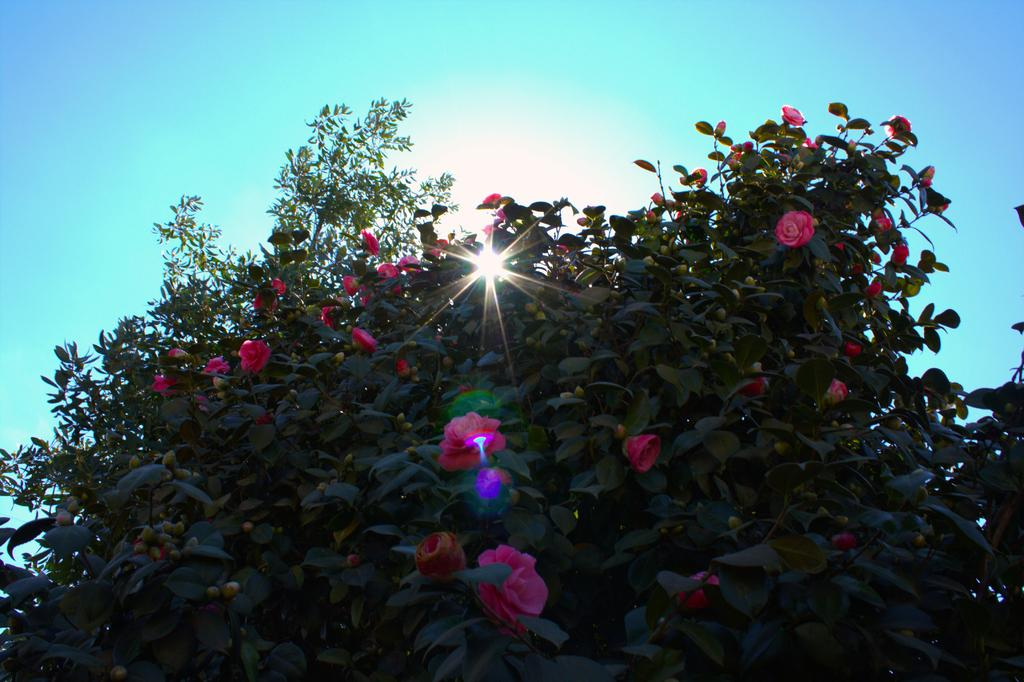What type of tree is in the image? There is a green color tree in the image. What can be seen in the background of the image? The sky is visible in the image. What song is being played in the room in the image? There is no room or song present in the image; it only features a green color tree and the sky. 